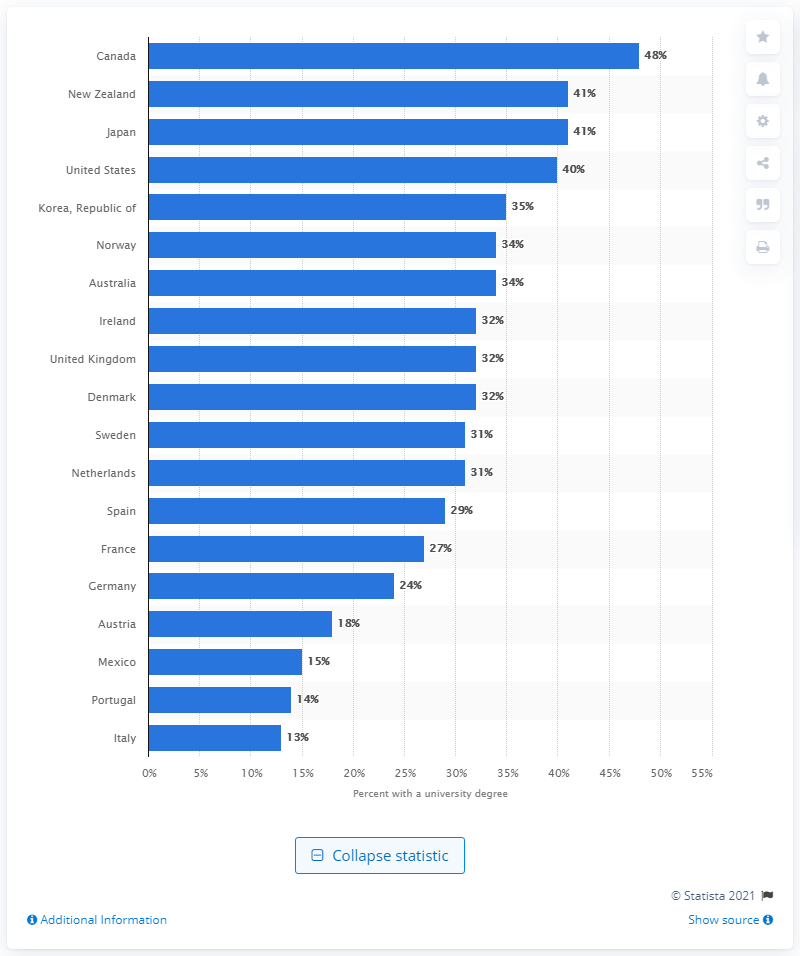List a handful of essential elements in this visual. In 2007, Canada had the highest percentage of adults with a university degree, among all countries. In 2007, Italy had the least number of people with a university degree among all countries. 